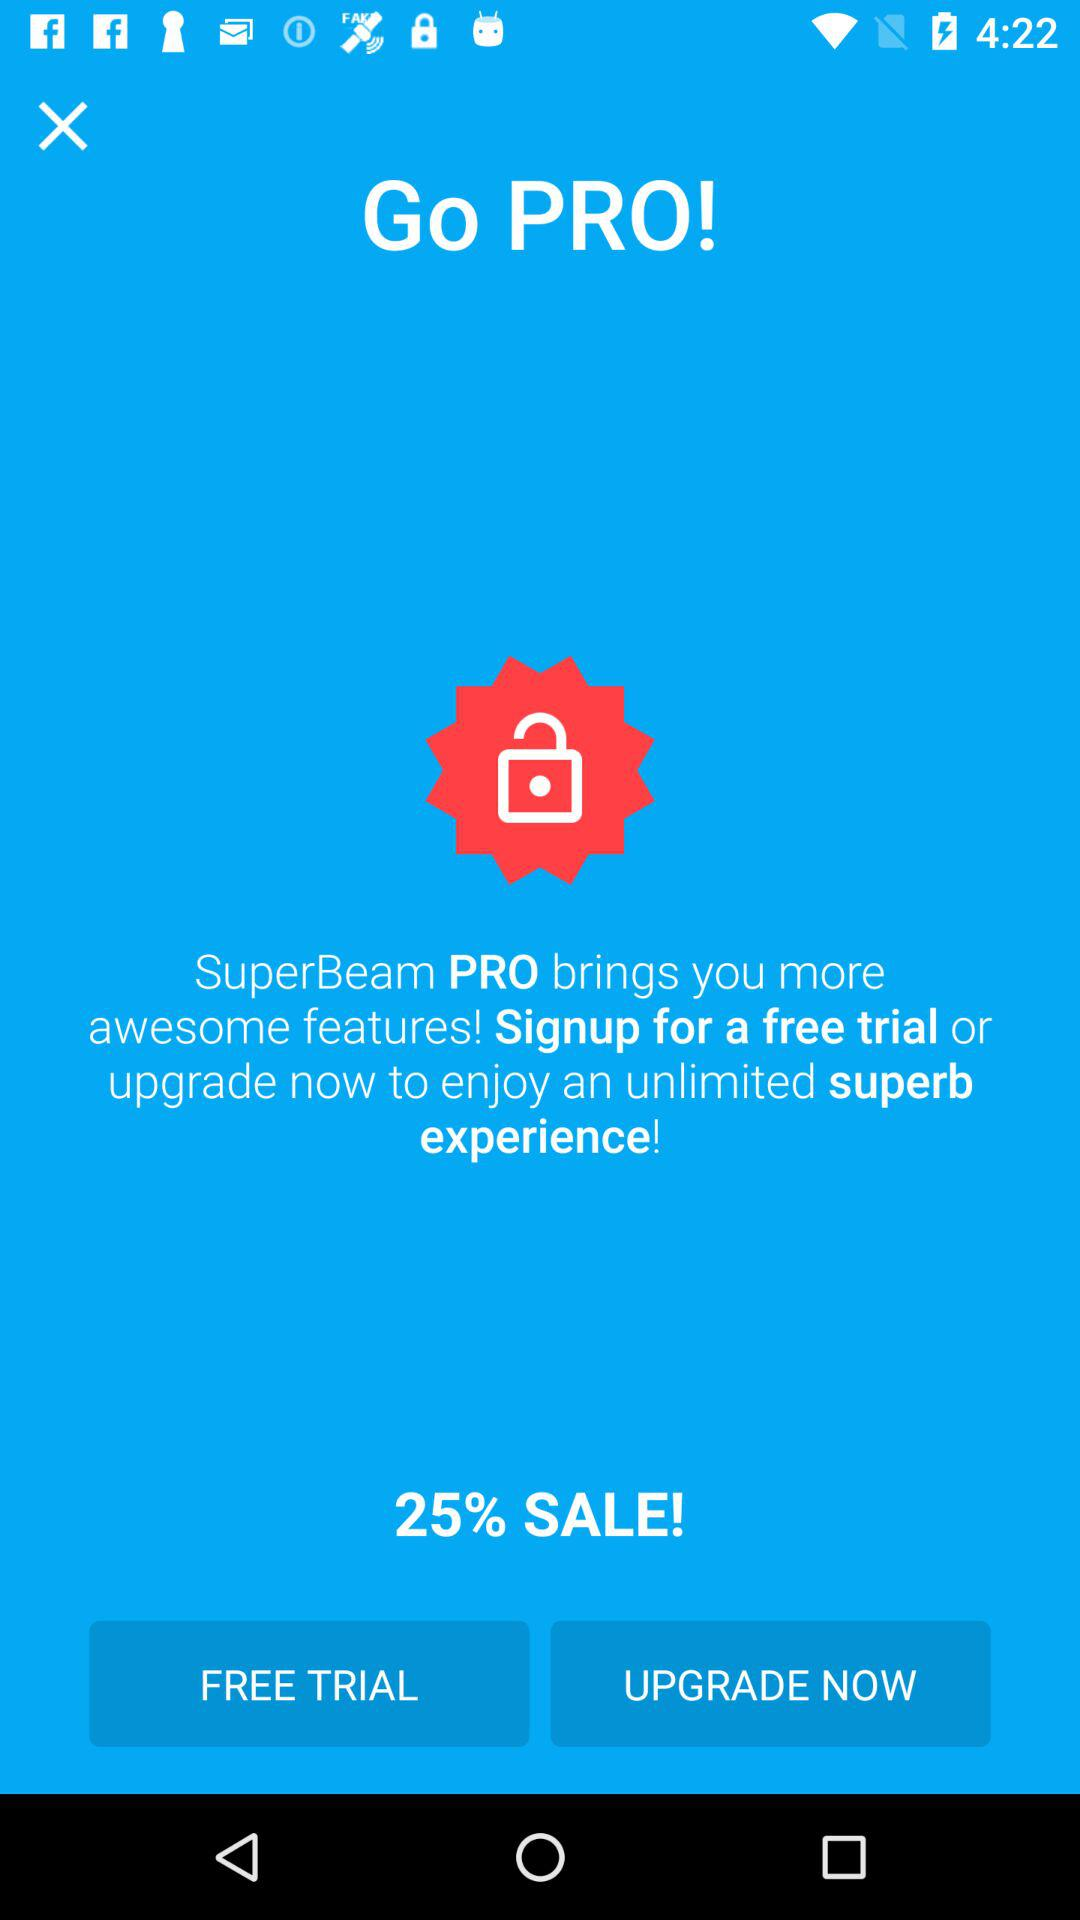What is the name of the application? The name of the application is "SuperBeam PRO". 